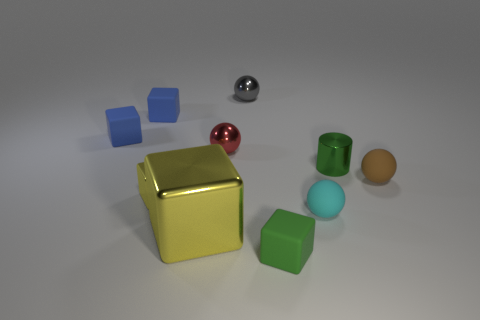There is a tiny green cylinder; what number of shiny things are behind it?
Offer a very short reply. 2. What is the shape of the small green object behind the small matte cube that is in front of the tiny cylinder?
Keep it short and to the point. Cylinder. Is there any other thing that is the same shape as the tiny yellow metal thing?
Provide a short and direct response. Yes. Are there more small matte things that are in front of the brown thing than green cylinders?
Provide a succinct answer. Yes. What number of cubes are behind the tiny object that is in front of the big block?
Provide a short and direct response. 4. What is the shape of the green thing that is to the right of the tiny matte sphere left of the tiny ball on the right side of the small cylinder?
Your response must be concise. Cylinder. Is there a big blue sphere made of the same material as the large yellow cube?
Your answer should be compact. No. There is another yellow object that is the same shape as the tiny yellow thing; what size is it?
Provide a succinct answer. Large. Is the number of red balls that are in front of the small green rubber thing the same as the number of big cyan metal spheres?
Provide a short and direct response. Yes. Do the yellow object that is to the right of the tiny yellow metallic object and the cyan matte object have the same shape?
Offer a very short reply. No. 